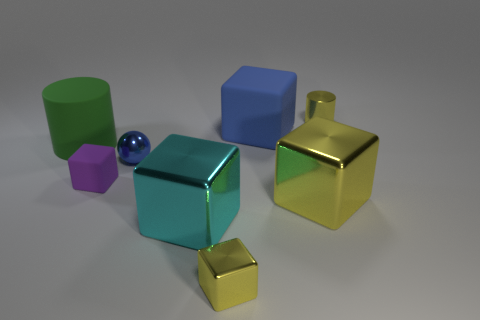There is a block that is the same color as the tiny shiny sphere; what is its material?
Make the answer very short. Rubber. There is a ball that is the same color as the large rubber cube; what is its size?
Your response must be concise. Small. Is there a big block of the same color as the tiny shiny cylinder?
Make the answer very short. Yes. Is there a small yellow metallic thing that is on the left side of the tiny yellow thing that is in front of the small purple block on the left side of the blue metallic thing?
Keep it short and to the point. No. There is a purple thing that is in front of the blue cube; what is it made of?
Make the answer very short. Rubber. Is the size of the matte cylinder the same as the cyan cube?
Give a very brief answer. Yes. There is a object that is both behind the blue metallic object and in front of the blue cube; what color is it?
Offer a terse response. Green. What shape is the tiny purple thing that is made of the same material as the big blue block?
Offer a very short reply. Cube. What number of cylinders are left of the blue block and behind the blue rubber cube?
Offer a terse response. 0. There is a tiny yellow shiny block; are there any tiny purple rubber things behind it?
Provide a short and direct response. Yes. 